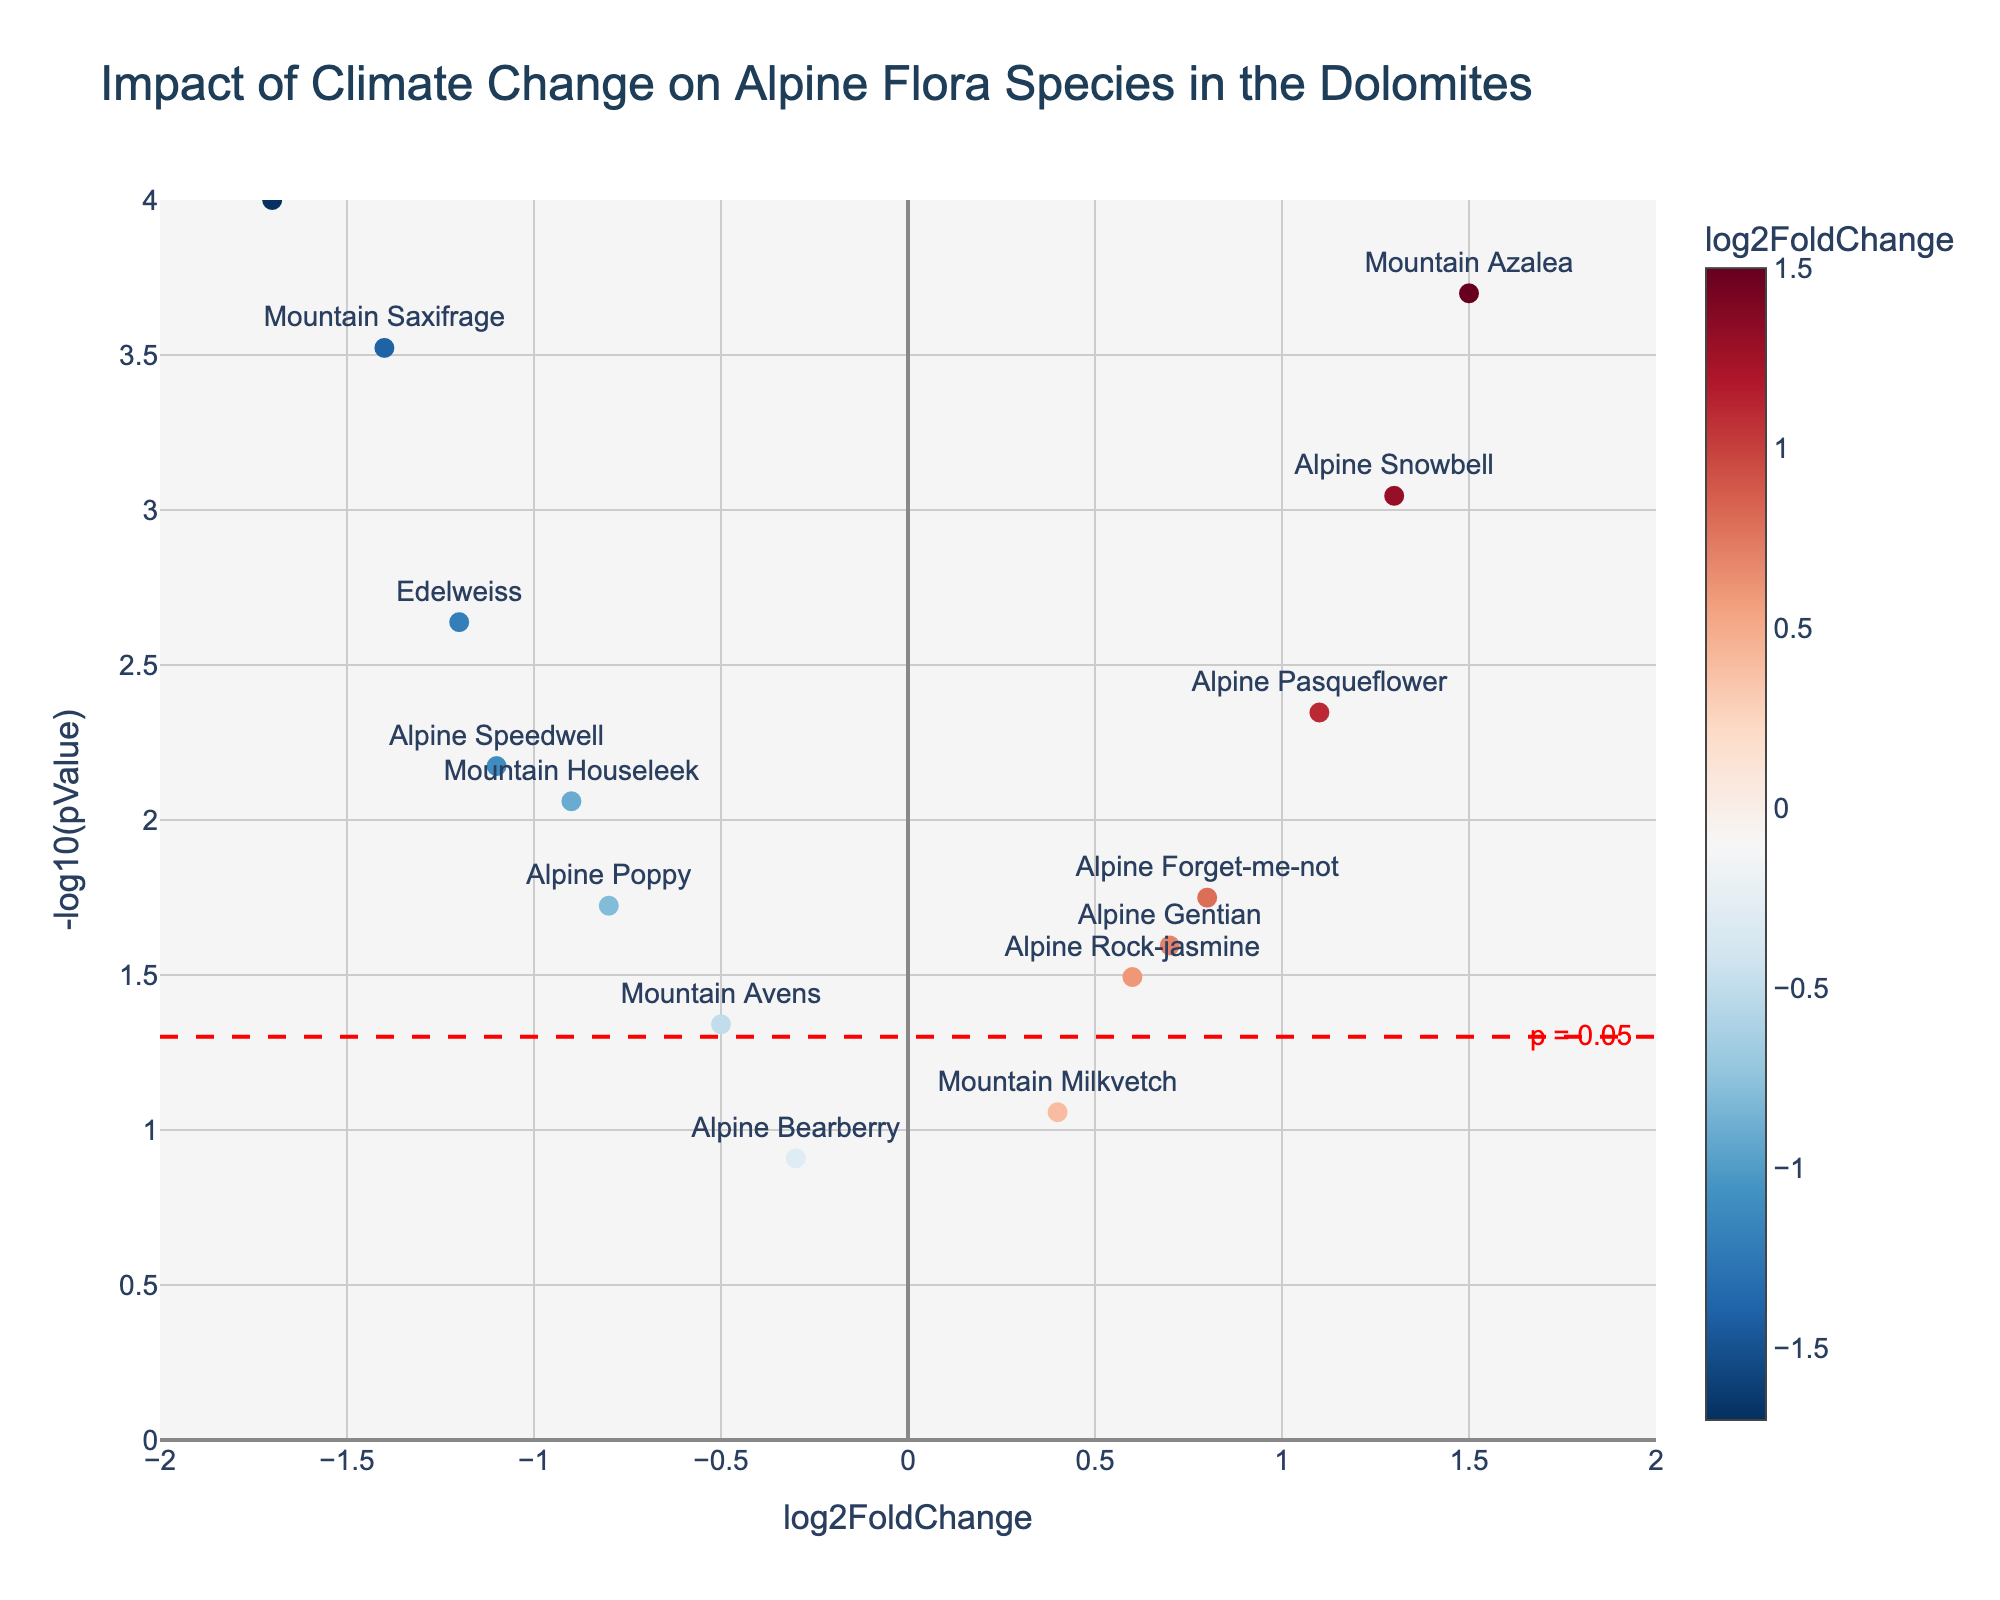What is the title of the figure? The title can be found at the top of the figure, typically in bold or a larger font size.
Answer: Impact of Climate Change on Alpine Flora Species in the Dolomites What do the x-axis and y-axis represent in the figure? The x-axis label indicates 'log2FoldChange,' and the y-axis label shows '-log10(pValue).' These represent the fold change in expression and the statistical significance of the changes, respectively.
Answer: log2FoldChange and -log10(pValue) What does a larger value on the y-axis indicate about a species' p-value? A larger value on the y-axis indicates a smaller p-value because the y-axis represents the negative logarithm of the p-value.
Answer: Smaller p-value Which species has the highest log2 fold change? By looking at the farthest point to the right on the x-axis, we can identify the species with the highest log2 fold change.
Answer: Mountain Azalea Which species shows the most significant decrease in abundance? The most significant decrease in abundance is indicated by the point farthest to the left on the x-axis (most negative log2FoldChange) and highest value on the y-axis (largest -log10(pValue)).
Answer: Glacier Buttercup How many species have a p-value less than 0.05? Species with a -log10(pValue) greater than -log10(0.05) (above the threshold line) have a p-value less than 0.05. Count the points above this line.
Answer: 11 What color gradient is used to represent log2FoldChange? The scatter plot color gradient varies by log2FoldChange value, typically using a colorscale like 'RdBu_r' (red-blue).
Answer: Red to Blue What does the red dashed line in the plot signify? The red dashed line at a specific y-value indicates the p-value threshold of 0.05. Points above this line are statistically significant.
Answer: p = 0.05 threshold Which species are closest to having no change in log2FoldChange? Species with log2FoldChange values close to zero (near the center of the x-axis) show little or no change. Identify the species around the (0, y) position.
Answer: Alpine Bearberry, Mountain Milkvetch Compare the significance levels of 'Mountain Saxifrage' and 'Mountain Houseleek.' Which one is more significant? Compare the y-values (-log10(pValue)) of the two species. The species with a higher y-value has a more significant p-value.
Answer: Mountain Saxifrage 